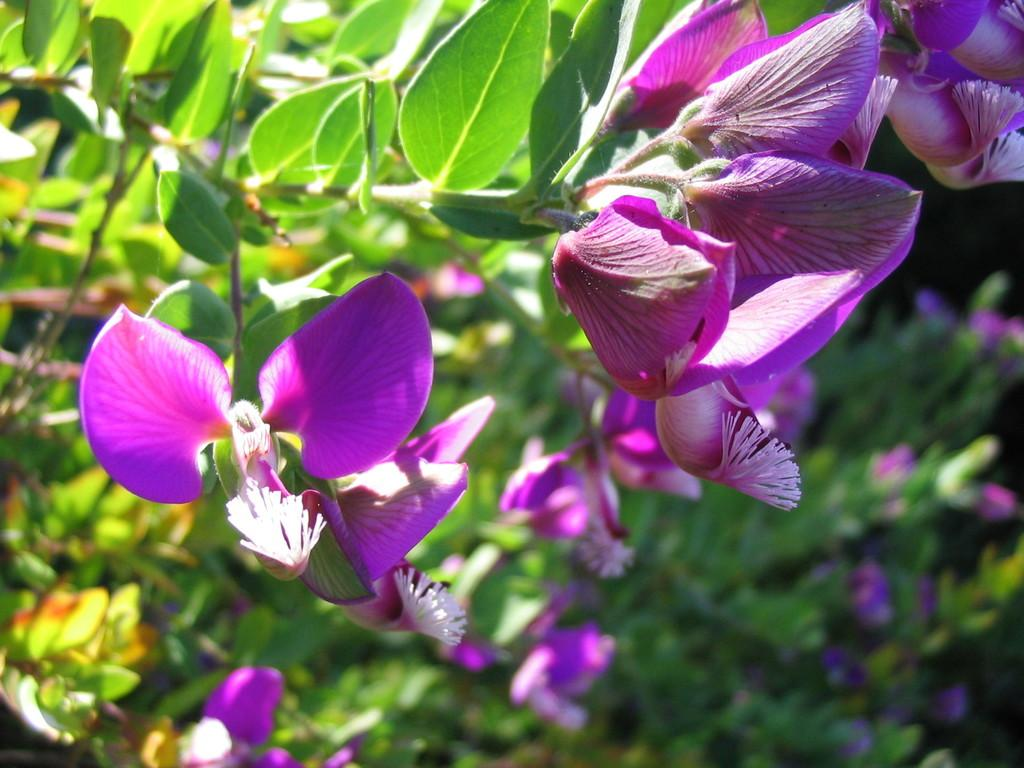What type of flowers can be seen on the plant in the image? There are violet flowers on a plant in the image. What type of engine is powering the machine in the image? There is no machine or engine present in the image; it features violet flowers on a plant. How many boys are visible in the image? There are no boys present in the image; it features violet flowers on a plant. 